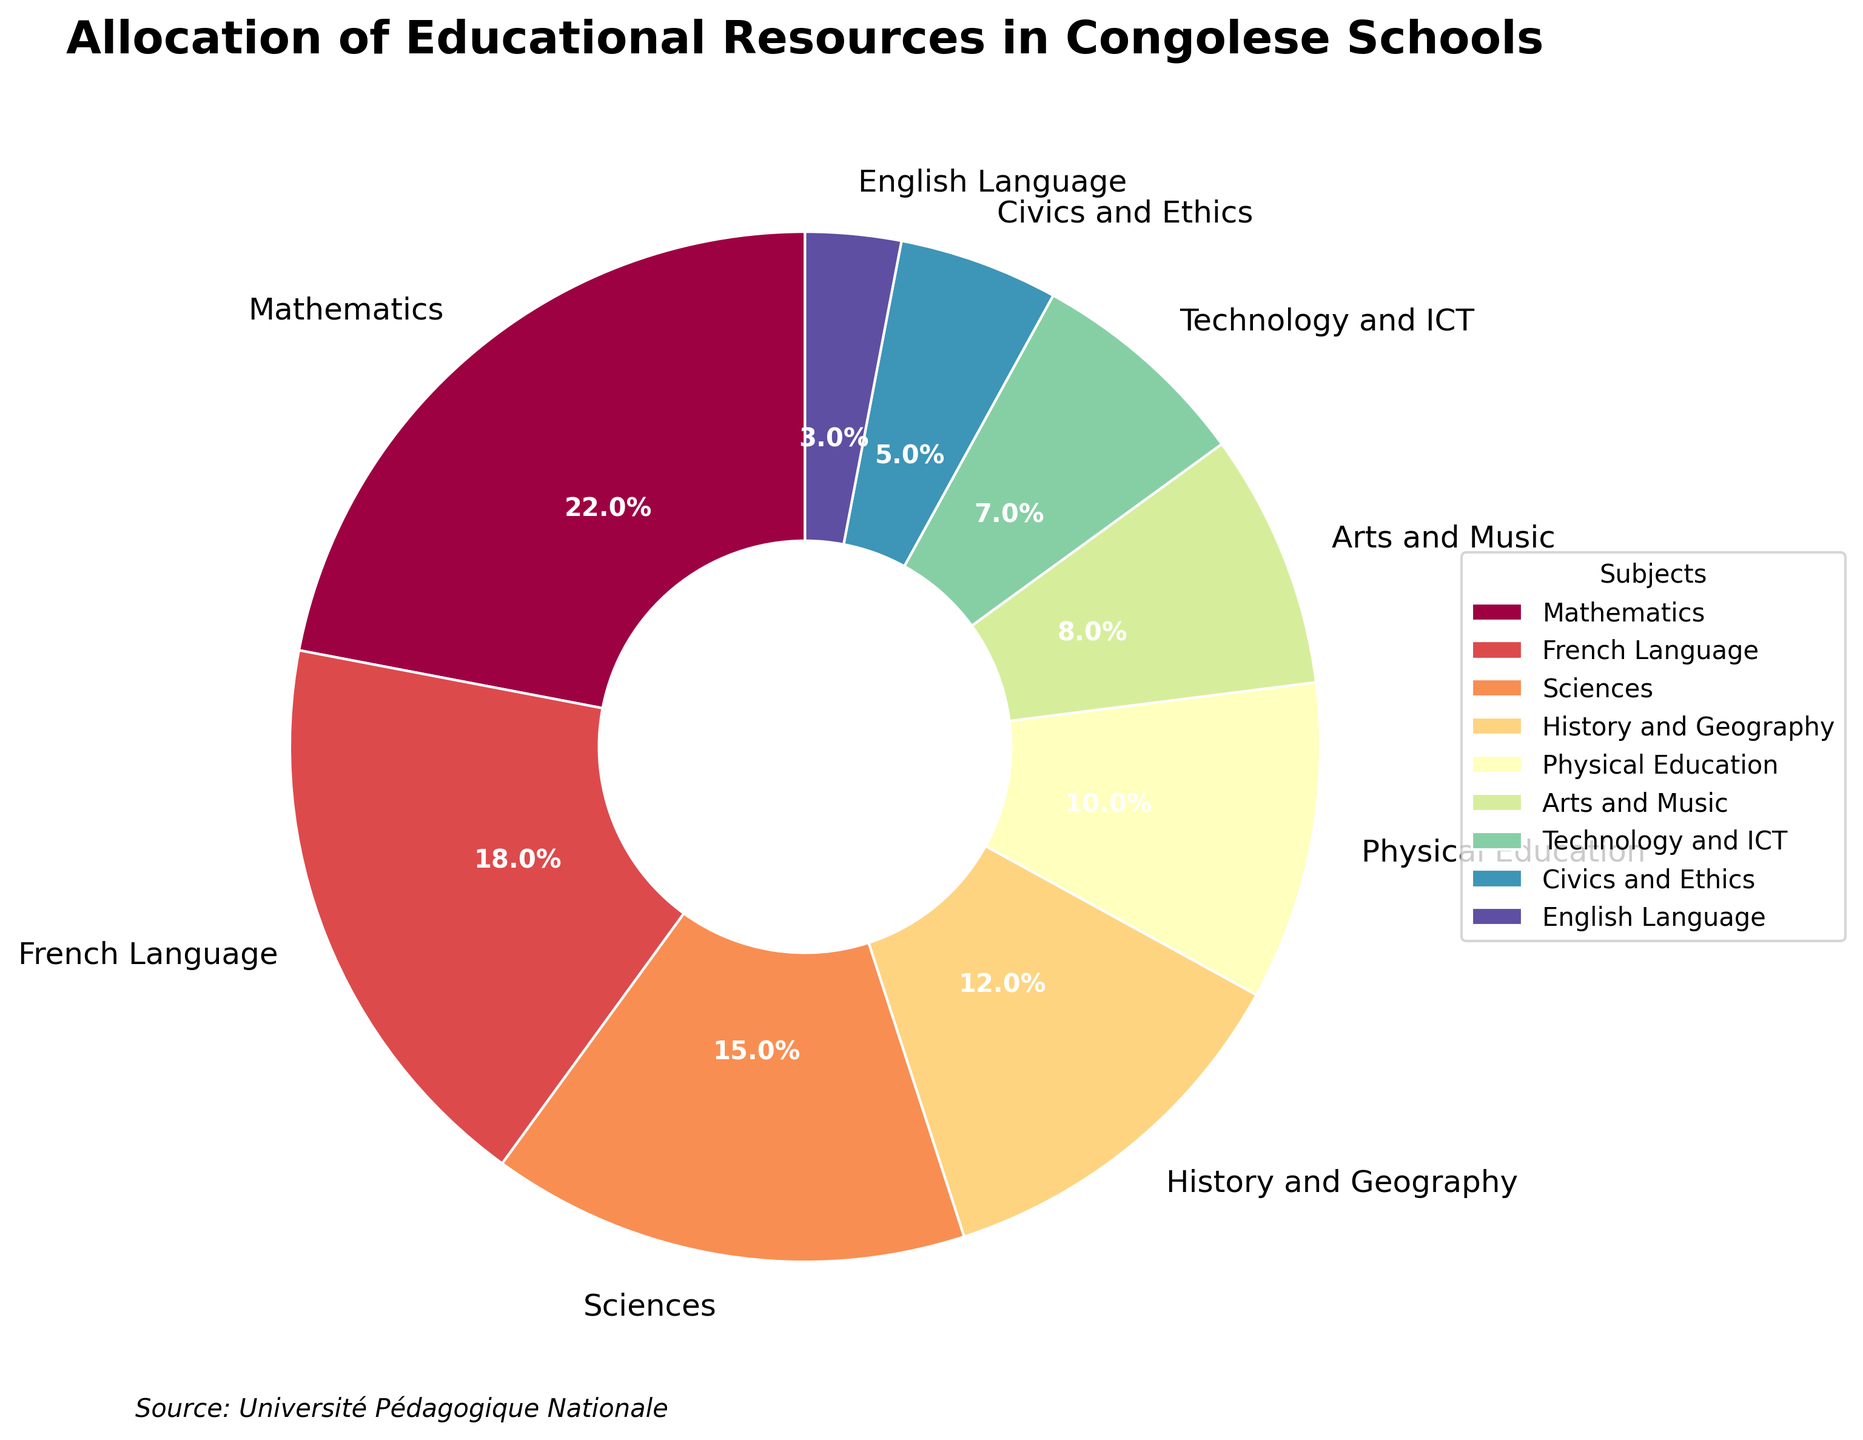What percentage of educational resources is allocated to Mathematics? The pie chart shows that the sector for Mathematics is labeled with 22%. By directly reading the percentage label, we can determine the allocation.
Answer: 22% What is the combined percentage of resources allocated to French Language and Sciences? The pie chart displays individual percentages for each subject. Adding the percentages for French Language (18%) and Sciences (15%) gives the combined percentage. 18% + 15% = 33%.
Answer: 33% Is the percentage of resources for Arts and Music greater or less than that for Physical Education? The chart shows that Arts and Music have a percentage of 8%, while Physical Education has 10%. Comparing these two values, we see that 8% is less than 10%.
Answer: Less What is the sum of the percentages for the three subjects with the smallest allocation? The three subjects with the smallest percentages are English Language (3%), Civics and Ethics (5%), and Technology and ICT (7%). Summing these values gives 3% + 5% + 7% = 15%.
Answer: 15% Which subject area receives the third largest amount of resources? The chart lists the percentages of resource allocation in descending order. The third largest percentage after Mathematics (22%) and French Language (18%) is Sciences (15%).
Answer: Sciences What percentage difference exists between the resources allocated to Technology and ICT versus Civics and Ethics? The percentages given for Technology and ICT are 7%, and for Civics and Ethics, it is 5%. The difference is calculated as 7% - 5% = 2%.
Answer: 2% Does History and Geography receive more resources than Physical Education? From the chart, History and Geography receives 12%, whereas Physical Education receives 10%. 12% is more than 10%, so the answer is yes.
Answer: Yes Which subjects together account for more than half of the total resources? By summing the percentages of the highest allocations until we exceed half (50%), we find that Mathematics (22%), French Language (18%), and Sciences (15%) together account for 22% + 18% + 15% = 55%.
Answer: Mathematics, French Language, Sciences How much more in percentage is allocated to Mathematics compared to English Language? Mathematics is allocated 22%, while English Language is allocated 3%. The difference is 22% - 3% = 19%.
Answer: 19% What color is used to represent the subject with the smallest allocation? The pie chart uses colors to differentiate subjects. The smallest allocation is for English Language, which is indicated by the color segment associated with 3%. Refer directly to the pie chart to identify the specific color used.
Answer: Varies (refer to pie chart) 